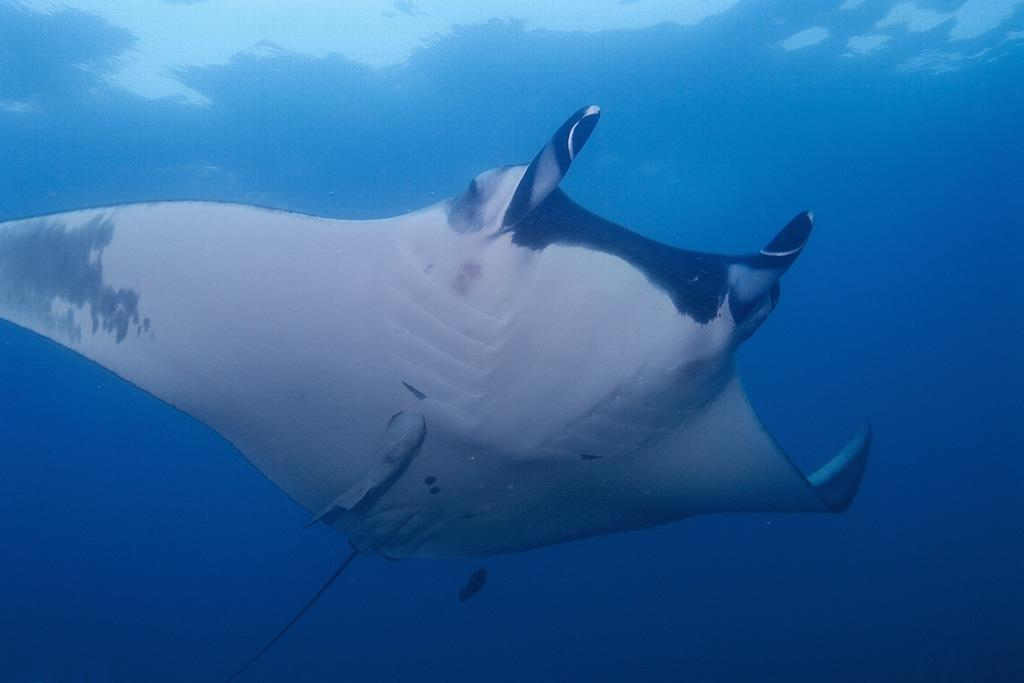What type of animal is in the image? There is a fish in the image. Where is the fish located? The fish is swimming underwater. What type of hole can be seen in the image? There is no hole present in the image; it features a fish swimming underwater. What is the fish doing with a comb in the image? There is no comb present in the image, and the fish is simply swimming underwater. 